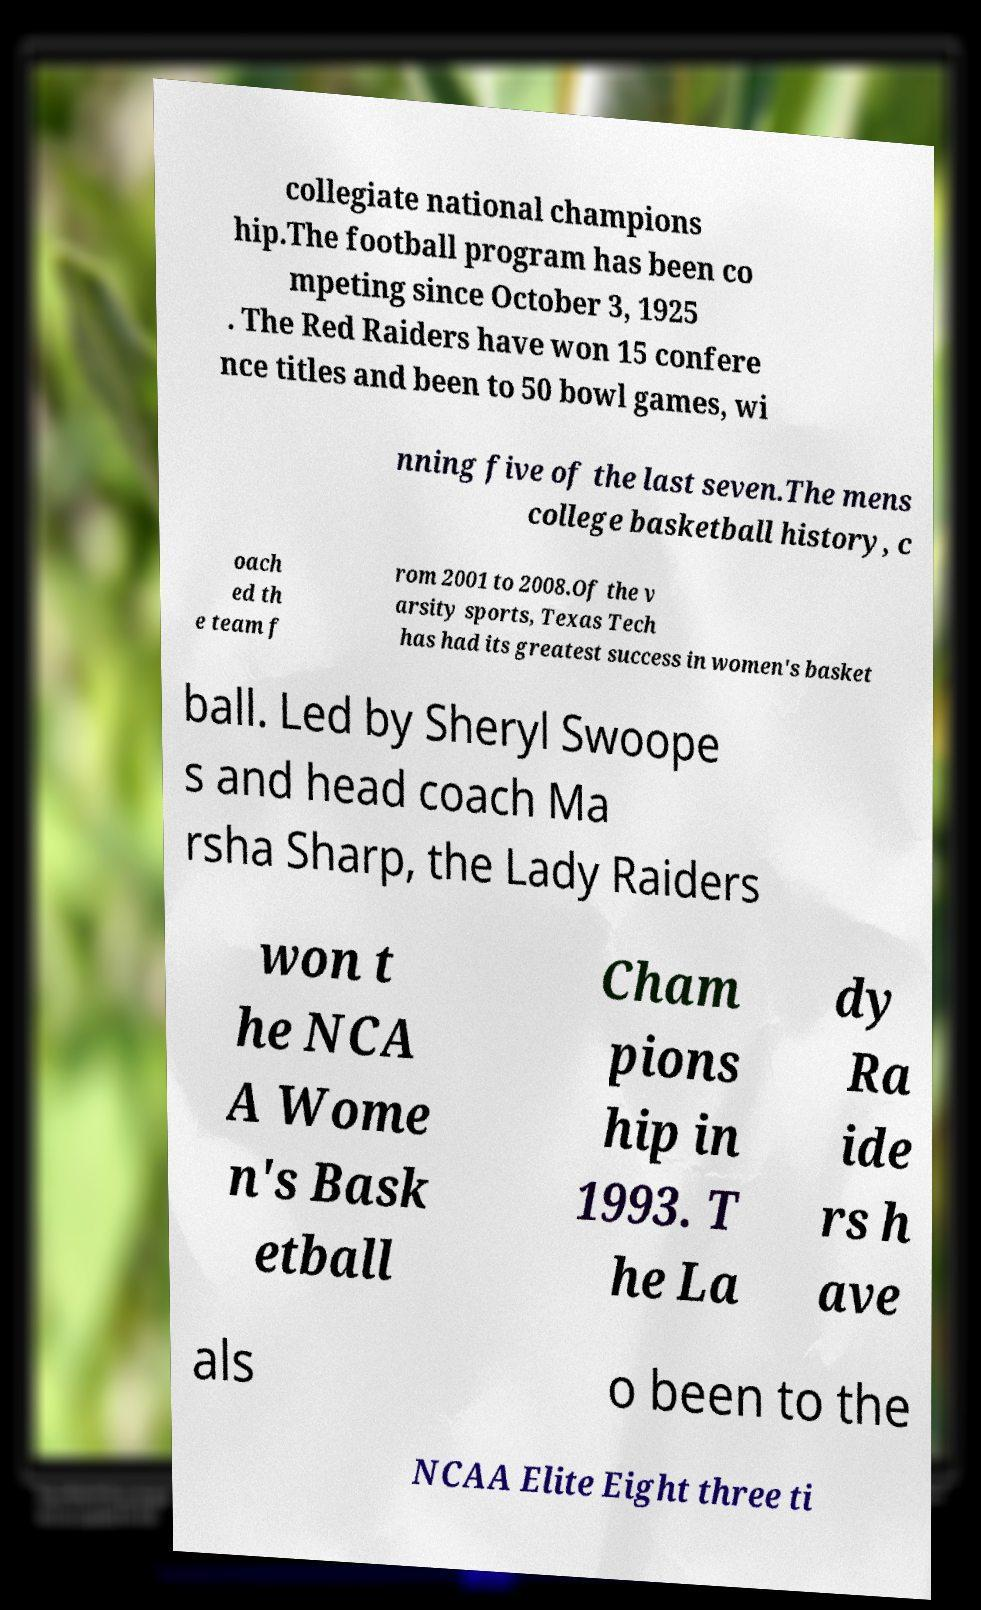Could you extract and type out the text from this image? collegiate national champions hip.The football program has been co mpeting since October 3, 1925 . The Red Raiders have won 15 confere nce titles and been to 50 bowl games, wi nning five of the last seven.The mens college basketball history, c oach ed th e team f rom 2001 to 2008.Of the v arsity sports, Texas Tech has had its greatest success in women's basket ball. Led by Sheryl Swoope s and head coach Ma rsha Sharp, the Lady Raiders won t he NCA A Wome n's Bask etball Cham pions hip in 1993. T he La dy Ra ide rs h ave als o been to the NCAA Elite Eight three ti 